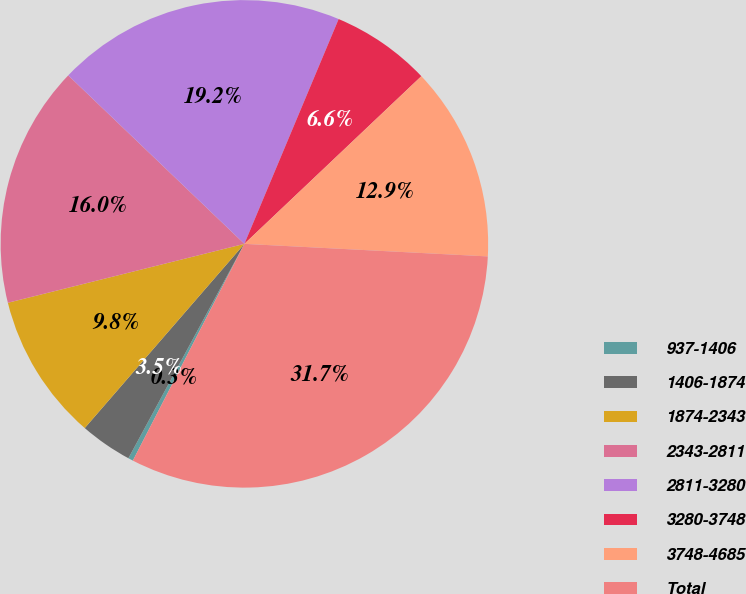<chart> <loc_0><loc_0><loc_500><loc_500><pie_chart><fcel>937-1406<fcel>1406-1874<fcel>1874-2343<fcel>2343-2811<fcel>2811-3280<fcel>3280-3748<fcel>3748-4685<fcel>Total<nl><fcel>0.33%<fcel>3.47%<fcel>9.75%<fcel>16.03%<fcel>19.17%<fcel>6.61%<fcel>12.89%<fcel>31.74%<nl></chart> 